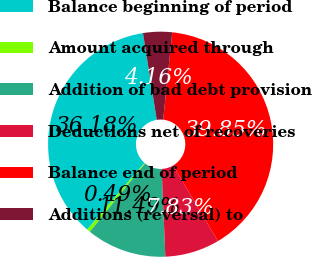<chart> <loc_0><loc_0><loc_500><loc_500><pie_chart><fcel>Balance beginning of period<fcel>Amount acquired through<fcel>Addition of bad debt provision<fcel>Deductions net of recoveries<fcel>Balance end of period<fcel>Additions (reversal) to<nl><fcel>36.18%<fcel>0.49%<fcel>11.49%<fcel>7.83%<fcel>39.85%<fcel>4.16%<nl></chart> 